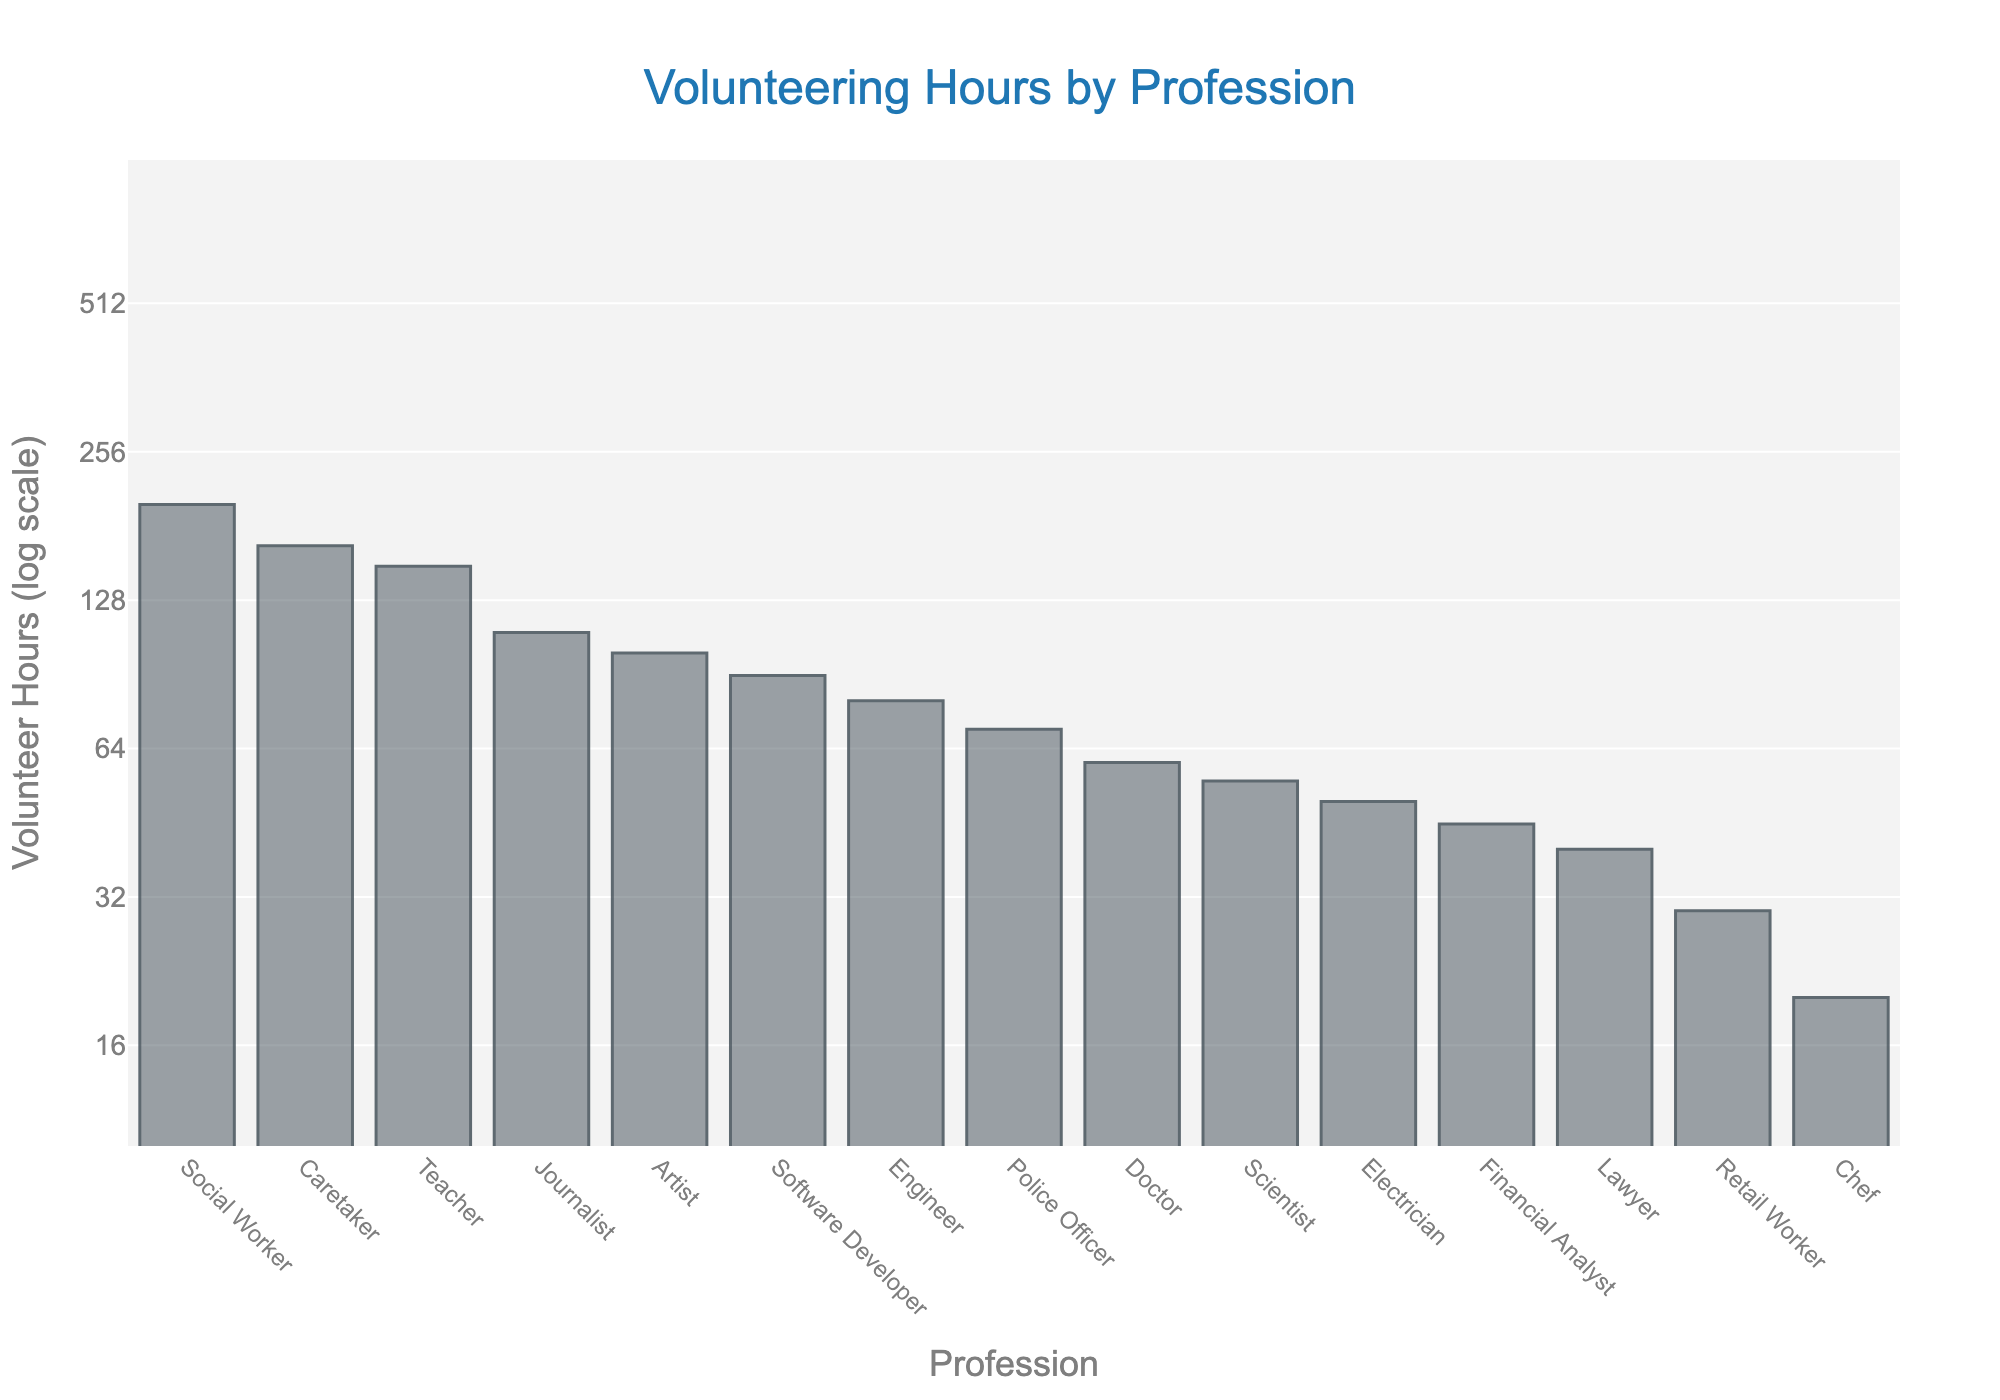What is the title of the plot? The title is the text at the top of the figure that describes what the plot is about. In this case, it is centered and written in larger font size.
Answer: Volunteering Hours by Profession Which profession has the highest volunteering hours? Look at the topmost bar in the plot, which represents the profession with the highest value on the y-axis.
Answer: Social Worker Which profession has the lowest volunteering hours? Look at the bottommost bar in the plot, which represents the profession with the lowest value on the y-axis.
Answer: Chef How many professions volunteer more than 100 hours? Count the number of bars that are above the 100-hour mark on the y-axis.
Answer: 5 What is the y-axis title? The y-axis title is the text next to the vertical axis describing what the y-axis values represent.
Answer: Volunteer Hours (log scale) What's the difference in volunteering hours between Journalists and Engineers? Find the bar heights for Journalists and Engineers, then subtract the smaller value from the larger value. For Journalists it's 110 hours and for Engineers it's 80 hours. So, 110 - 80 = 30.
Answer: 30 Which professions have more volunteering hours than Doctors? Identify the bars for professions that have a higher value on the y-axis compared to Doctors. Doctors have 60 volunteering hours, so look for bars that exceed this height.
Answer: Teacher, Artist, Software Developer, Social Worker, Journalist, Caretaker What is the ratio of volunteering hours between Social Workers and Retail Workers? Find the bar heights for Social Workers and Retail Workers, then divide the height of Social Workers by Retail Workers. For Social Workers it’s 200 hours and for Retail Workers it’s 30 hours. So, 200 / 30 = approximately 6.67.
Answer: 6.67 How many professions volunteer less than 50 hours? Count the number of bars that are below the 50-hour mark on the y-axis.
Answer: 4 Which profession appears exactly in the middle if we rank them by volunteer hours? Sort the professions by the heights of their bars and find the one in the middle position.
Answer: Scientist 